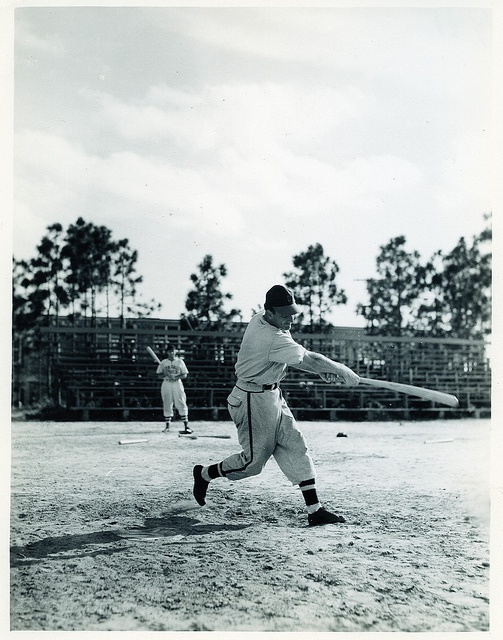Describe the objects in this image and their specific colors. I can see people in ivory, gray, black, and darkgray tones, people in ivory, darkgray, gray, and black tones, baseball bat in ivory, darkgray, black, gray, and lightgray tones, bench in black and ivory tones, and bench in ivory, black, and purple tones in this image. 